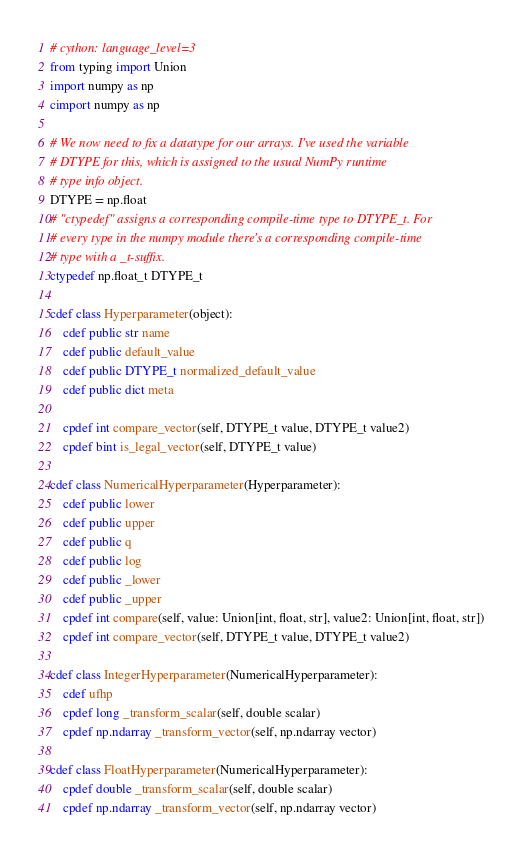<code> <loc_0><loc_0><loc_500><loc_500><_Cython_># cython: language_level=3
from typing import Union
import numpy as np
cimport numpy as np

# We now need to fix a datatype for our arrays. I've used the variable
# DTYPE for this, which is assigned to the usual NumPy runtime
# type info object.
DTYPE = np.float
# "ctypedef" assigns a corresponding compile-time type to DTYPE_t. For
# every type in the numpy module there's a corresponding compile-time
# type with a _t-suffix.
ctypedef np.float_t DTYPE_t

cdef class Hyperparameter(object):
    cdef public str name
    cdef public default_value
    cdef public DTYPE_t normalized_default_value
    cdef public dict meta

    cpdef int compare_vector(self, DTYPE_t value, DTYPE_t value2)
    cpdef bint is_legal_vector(self, DTYPE_t value)

cdef class NumericalHyperparameter(Hyperparameter):
    cdef public lower
    cdef public upper
    cdef public q
    cdef public log
    cdef public _lower
    cdef public _upper
    cpdef int compare(self, value: Union[int, float, str], value2: Union[int, float, str])
    cpdef int compare_vector(self, DTYPE_t value, DTYPE_t value2)

cdef class IntegerHyperparameter(NumericalHyperparameter):
    cdef ufhp
    cpdef long _transform_scalar(self, double scalar)
    cpdef np.ndarray _transform_vector(self, np.ndarray vector)

cdef class FloatHyperparameter(NumericalHyperparameter):
    cpdef double _transform_scalar(self, double scalar)
    cpdef np.ndarray _transform_vector(self, np.ndarray vector)</code> 